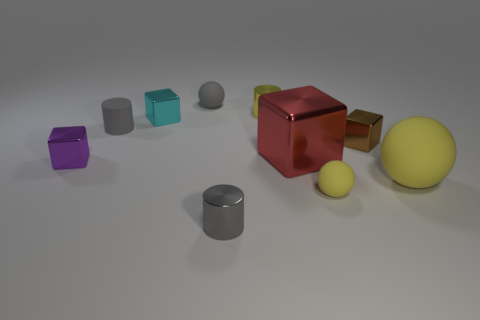What is the material of the small sphere that is the same color as the big rubber ball?
Your response must be concise. Rubber. How many objects are tiny metallic things that are in front of the rubber cylinder or things left of the big red metallic thing?
Offer a terse response. 7. What number of other things are there of the same color as the big matte object?
Offer a terse response. 2. Is the shape of the tiny purple object the same as the yellow rubber object to the right of the brown object?
Provide a short and direct response. No. Are there fewer tiny gray cylinders behind the matte cylinder than yellow spheres that are on the right side of the tiny yellow matte object?
Offer a terse response. Yes. There is a tiny cyan thing that is the same shape as the big red thing; what material is it?
Your response must be concise. Metal. Is there anything else that is made of the same material as the brown object?
Offer a terse response. Yes. Do the big metallic block and the small rubber cylinder have the same color?
Offer a terse response. No. The big object that is the same material as the small yellow sphere is what shape?
Your answer should be very brief. Sphere. What number of tiny cyan things have the same shape as the purple shiny object?
Offer a very short reply. 1. 